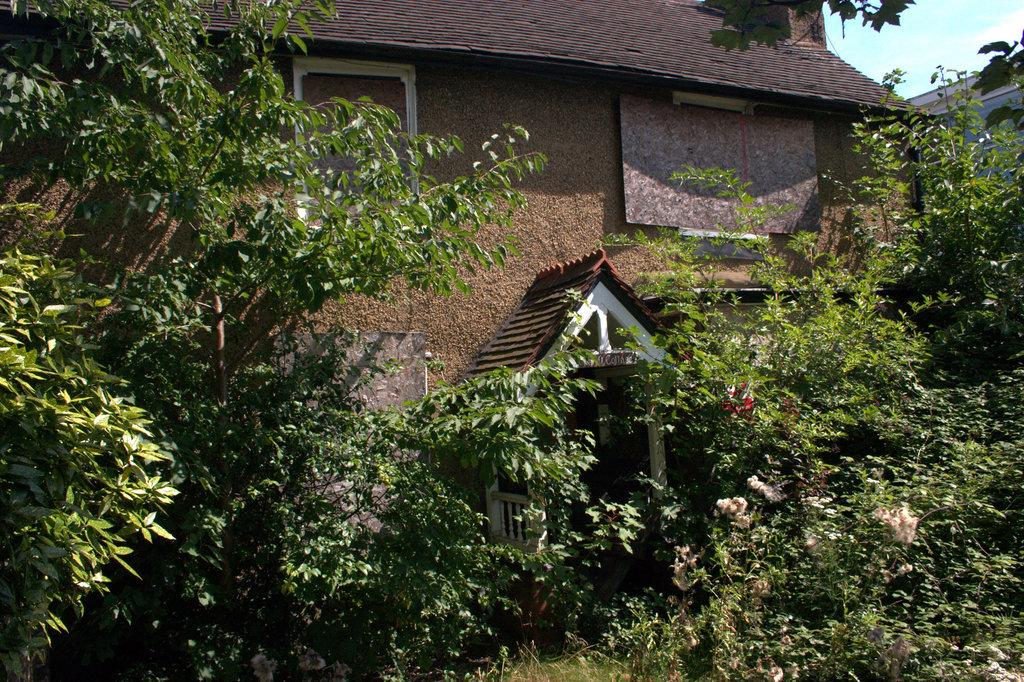What type of structure is visible in the image? There is a house in the image. What can be seen in front of the house? There are trees and plants in front of the house. What type of fly is buzzing around the house in the image? There is no fly visible in the image. 